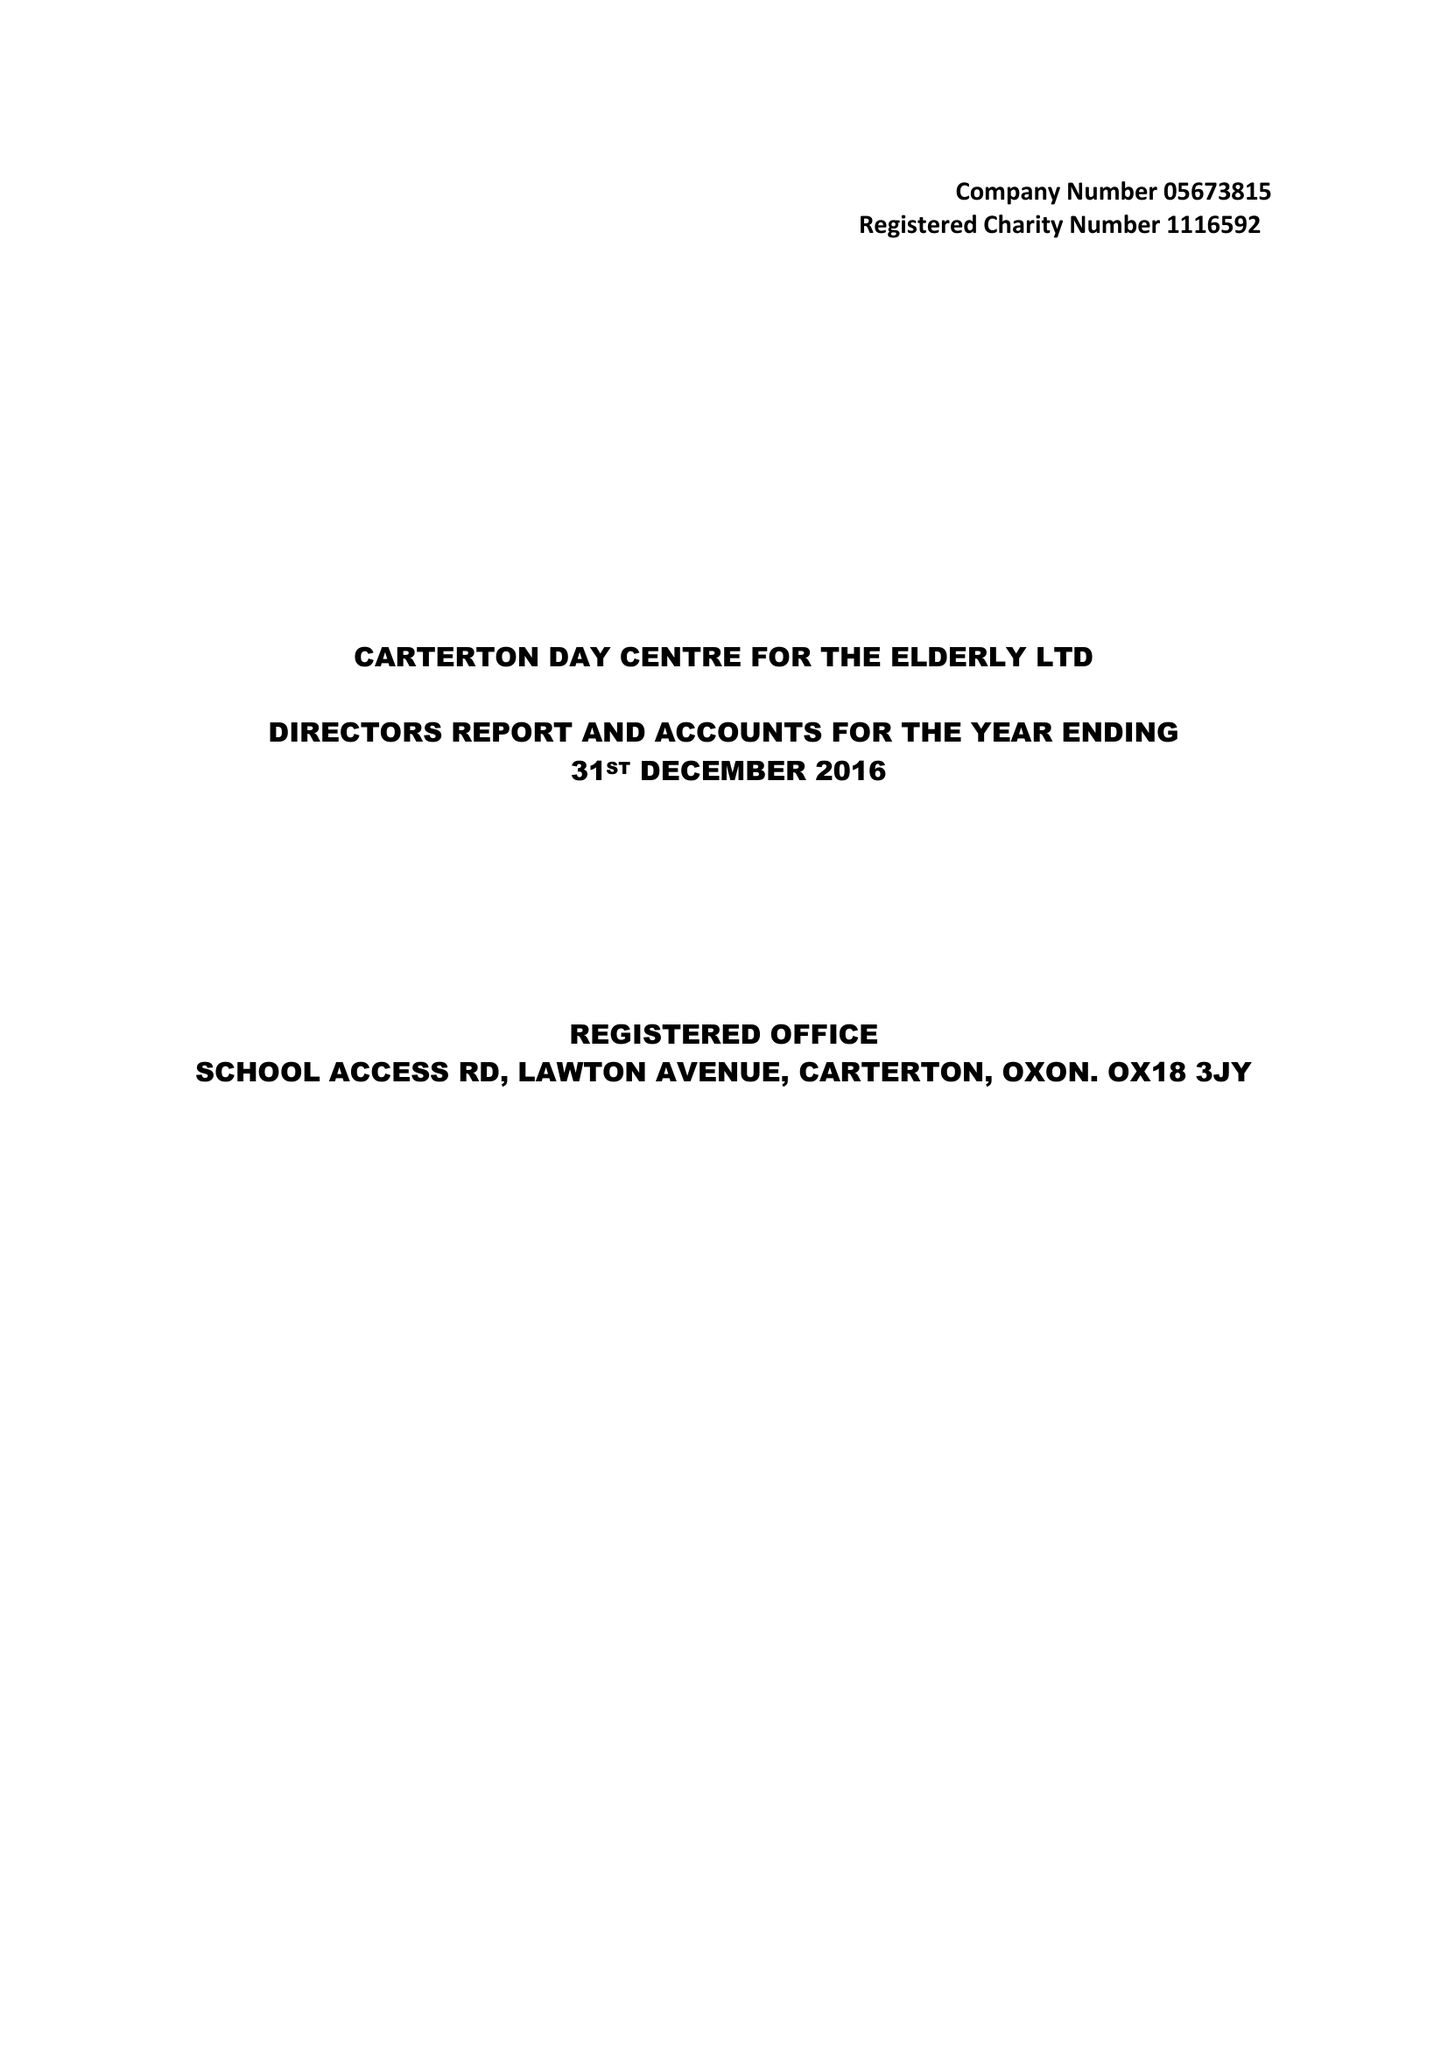What is the value for the spending_annually_in_british_pounds?
Answer the question using a single word or phrase. 40493.00 